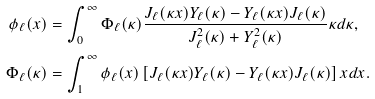Convert formula to latex. <formula><loc_0><loc_0><loc_500><loc_500>\phi _ { \ell } ( x ) & = \int _ { 0 } ^ { \infty } \Phi _ { \ell } ( \kappa ) \frac { J _ { \ell } ( \kappa x ) Y _ { \ell } ( \kappa ) - Y _ { \ell } ( \kappa x ) J _ { \ell } ( \kappa ) } { J _ { \ell } ^ { 2 } ( \kappa ) + Y _ { \ell } ^ { 2 } ( \kappa ) } \kappa d \kappa , \\ \Phi _ { \ell } ( \kappa ) & = \int _ { 1 } ^ { \infty } \phi _ { \ell } ( x ) \left [ J _ { \ell } ( \kappa x ) Y _ { \ell } ( \kappa ) - Y _ { \ell } ( \kappa x ) J _ { \ell } ( \kappa ) \right ] x d x .</formula> 